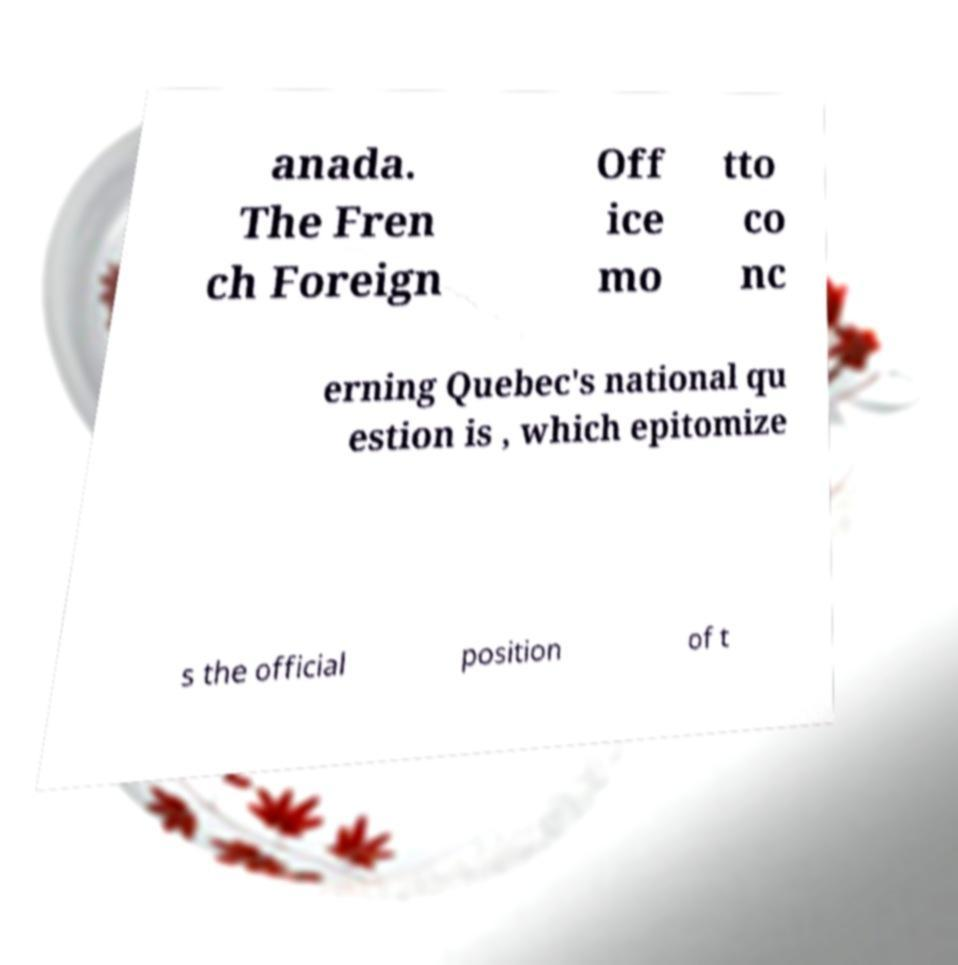Can you read and provide the text displayed in the image?This photo seems to have some interesting text. Can you extract and type it out for me? anada. The Fren ch Foreign Off ice mo tto co nc erning Quebec's national qu estion is , which epitomize s the official position of t 